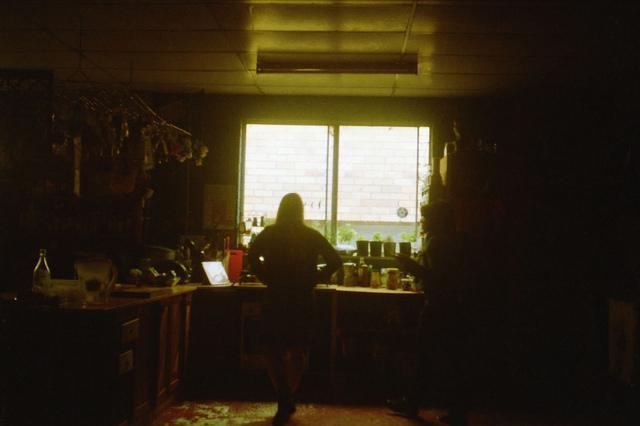How many people do you see?
Give a very brief answer. 1. How many people can you see?
Give a very brief answer. 2. How many white cars are on the road?
Give a very brief answer. 0. 